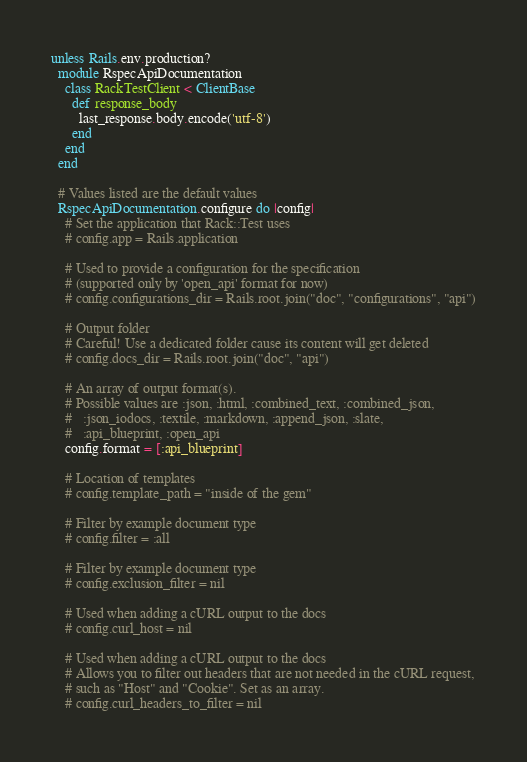Convert code to text. <code><loc_0><loc_0><loc_500><loc_500><_Ruby_>unless Rails.env.production?
  module RspecApiDocumentation
    class RackTestClient < ClientBase
      def response_body
        last_response.body.encode('utf-8')
      end
    end
  end

  # Values listed are the default values
  RspecApiDocumentation.configure do |config|
    # Set the application that Rack::Test uses
    # config.app = Rails.application

    # Used to provide a configuration for the specification
    # (supported only by 'open_api' format for now)
    # config.configurations_dir = Rails.root.join("doc", "configurations", "api")

    # Output folder
    # Careful! Use a dedicated folder cause its content will get deleted
    # config.docs_dir = Rails.root.join("doc", "api")

    # An array of output format(s).
    # Possible values are :json, :html, :combined_text, :combined_json,
    #   :json_iodocs, :textile, :markdown, :append_json, :slate,
    #   :api_blueprint, :open_api
    config.format = [:api_blueprint]

    # Location of templates
    # config.template_path = "inside of the gem"

    # Filter by example document type
    # config.filter = :all

    # Filter by example document type
    # config.exclusion_filter = nil

    # Used when adding a cURL output to the docs
    # config.curl_host = nil

    # Used when adding a cURL output to the docs
    # Allows you to filter out headers that are not needed in the cURL request,
    # such as "Host" and "Cookie". Set as an array.
    # config.curl_headers_to_filter = nil
</code> 